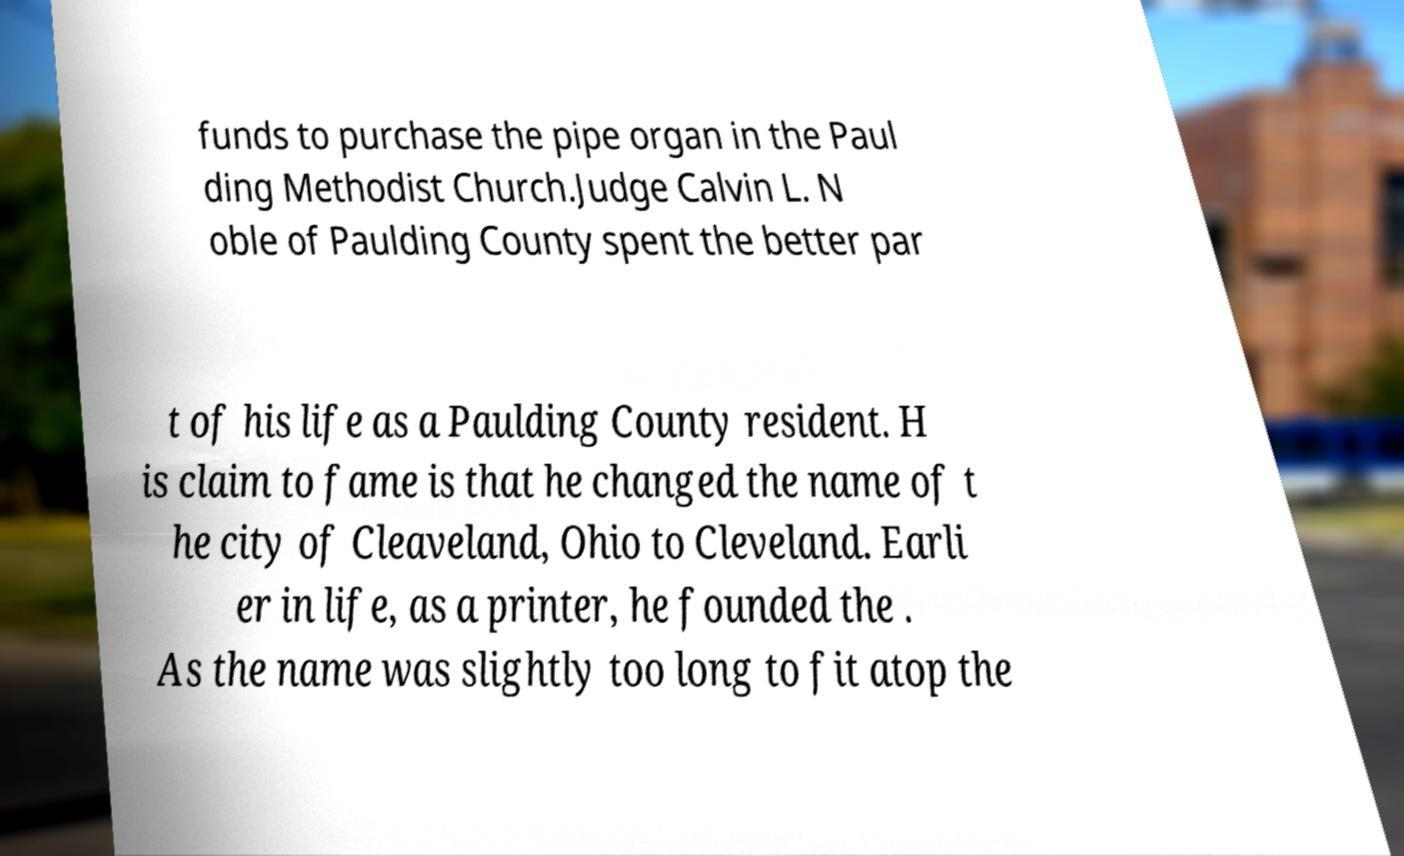For documentation purposes, I need the text within this image transcribed. Could you provide that? funds to purchase the pipe organ in the Paul ding Methodist Church.Judge Calvin L. N oble of Paulding County spent the better par t of his life as a Paulding County resident. H is claim to fame is that he changed the name of t he city of Cleaveland, Ohio to Cleveland. Earli er in life, as a printer, he founded the . As the name was slightly too long to fit atop the 